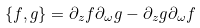Convert formula to latex. <formula><loc_0><loc_0><loc_500><loc_500>\{ f , g \} = \partial _ { z } f \partial _ { \omega } g - \partial _ { z } g \partial _ { \omega } f</formula> 